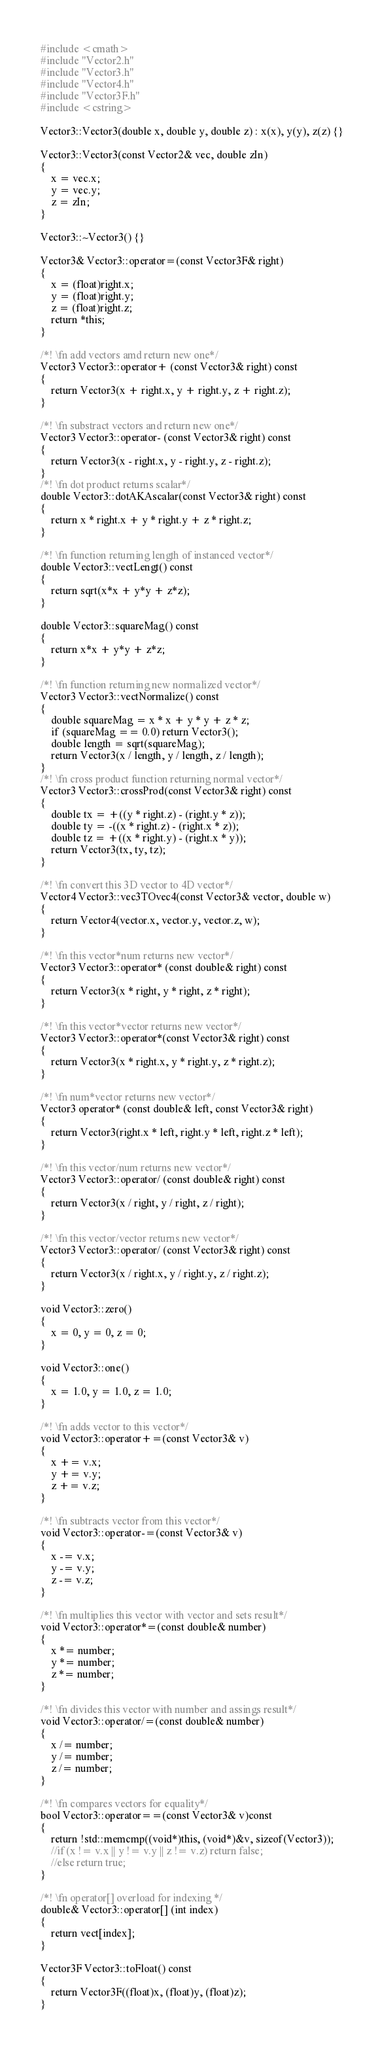Convert code to text. <code><loc_0><loc_0><loc_500><loc_500><_C++_>#include <cmath>
#include "Vector2.h"
#include "Vector3.h"
#include "Vector4.h"
#include "Vector3F.h"
#include <cstring>

Vector3::Vector3(double x, double y, double z) : x(x), y(y), z(z) {}

Vector3::Vector3(const Vector2& vec, double zIn)
{
	x = vec.x;
	y = vec.y;
	z = zIn;
}

Vector3::~Vector3() {}

Vector3& Vector3::operator=(const Vector3F& right)
{
	x = (float)right.x;
	y = (float)right.y;
	z = (float)right.z;
	return *this;
}

/*! \fn add vectors amd return new one*/
Vector3 Vector3::operator+ (const Vector3& right) const
{
	return Vector3(x + right.x, y + right.y, z + right.z);
}

/*! \fn substract vectors and return new one*/
Vector3 Vector3::operator- (const Vector3& right) const
{
	return Vector3(x - right.x, y - right.y, z - right.z);
}
/*! \fn dot product returns scalar*/
double Vector3::dotAKAscalar(const Vector3& right) const
{
	return x * right.x + y * right.y + z * right.z;
}

/*! \fn function returning length of instanced vector*/
double Vector3::vectLengt() const
{
	return sqrt(x*x + y*y + z*z);
}

double Vector3::squareMag() const
{
	return x*x + y*y + z*z;
}

/*! \fn function returning new normalized vector*/
Vector3 Vector3::vectNormalize() const
{
	double squareMag = x * x + y * y + z * z;
	if (squareMag == 0.0) return Vector3();
	double length = sqrt(squareMag);
	return Vector3(x / length, y / length, z / length);
}
/*! \fn cross product function returning normal vector*/
Vector3 Vector3::crossProd(const Vector3& right) const
{
	double tx = +((y * right.z) - (right.y * z));
	double ty = -((x * right.z) - (right.x * z));
	double tz = +((x * right.y) - (right.x * y));
	return Vector3(tx, ty, tz);
}

/*! \fn convert this 3D vector to 4D vector*/
Vector4 Vector3::vec3TOvec4(const Vector3& vector, double w)
{
	return Vector4(vector.x, vector.y, vector.z, w);
}

/*! \fn this vector*num returns new vector*/
Vector3 Vector3::operator* (const double& right) const
{
	return Vector3(x * right, y * right, z * right);
}

/*! \fn this vector*vector returns new vector*/
Vector3 Vector3::operator*(const Vector3& right) const
{
	return Vector3(x * right.x, y * right.y, z * right.z);
}

/*! \fn num*vector returns new vector*/
Vector3 operator* (const double& left, const Vector3& right)
{
	return Vector3(right.x * left, right.y * left, right.z * left);
}

/*! \fn this vector/num returns new vector*/
Vector3 Vector3::operator/ (const double& right) const
{
	return Vector3(x / right, y / right, z / right);
}

/*! \fn this vector/vector returns new vector*/
Vector3 Vector3::operator/ (const Vector3& right) const
{
	return Vector3(x / right.x, y / right.y, z / right.z);
}

void Vector3::zero()
{
	x = 0, y = 0, z = 0;
}

void Vector3::one()
{
	x = 1.0, y = 1.0, z = 1.0;
}

/*! \fn adds vector to this vector*/
void Vector3::operator+=(const Vector3& v)
{
	x += v.x;
	y += v.y;
	z += v.z;
}

/*! \fn subtracts vector from this vector*/
void Vector3::operator-=(const Vector3& v)
{
	x -= v.x;
	y -= v.y;
	z -= v.z;
}

/*! \fn multiplies this vector with vector and sets result*/
void Vector3::operator*=(const double& number)
{
	x *= number;
	y *= number;
	z *= number;
}

/*! \fn divides this vector with number and assings result*/
void Vector3::operator/=(const double& number)
{
	x /= number;
	y /= number;
	z /= number;
}

/*! \fn compares vectors for equality*/
bool Vector3::operator==(const Vector3& v)const
{
	return !std::memcmp((void*)this, (void*)&v, sizeof(Vector3));
	//if (x != v.x || y != v.y || z != v.z) return false;	
	//else return true;
}

/*! \fn operator[] overload for indexing */
double& Vector3::operator[] (int index)
{
	return vect[index];
}

Vector3F Vector3::toFloat() const
{
	return Vector3F((float)x, (float)y, (float)z);
}</code> 